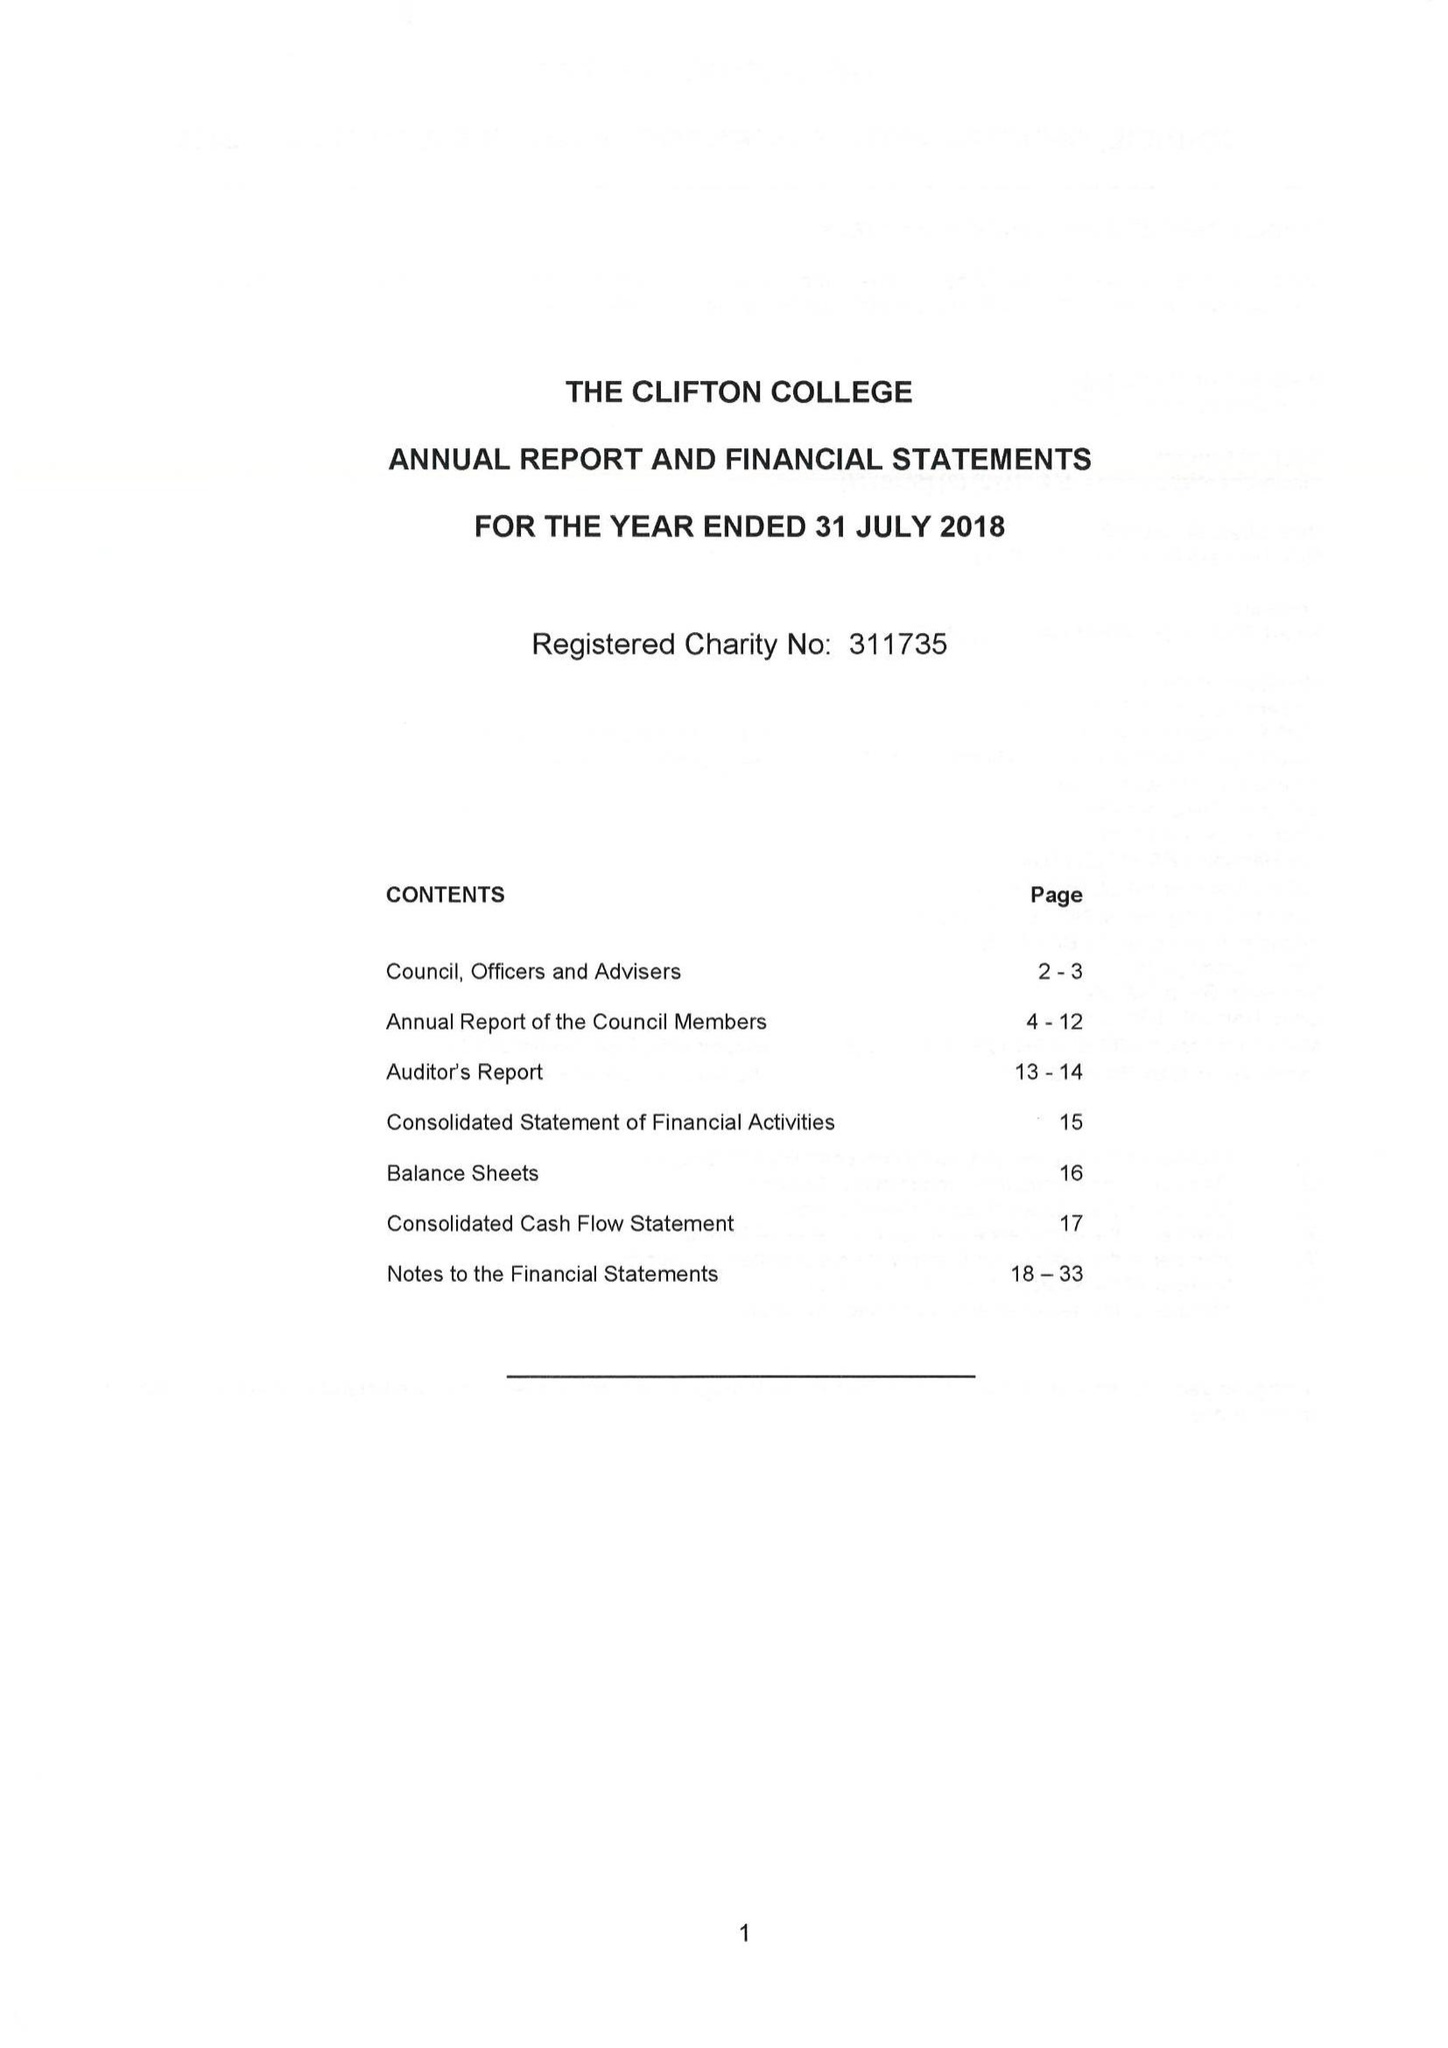What is the value for the report_date?
Answer the question using a single word or phrase. 2018-07-31 